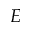<formula> <loc_0><loc_0><loc_500><loc_500>E</formula> 